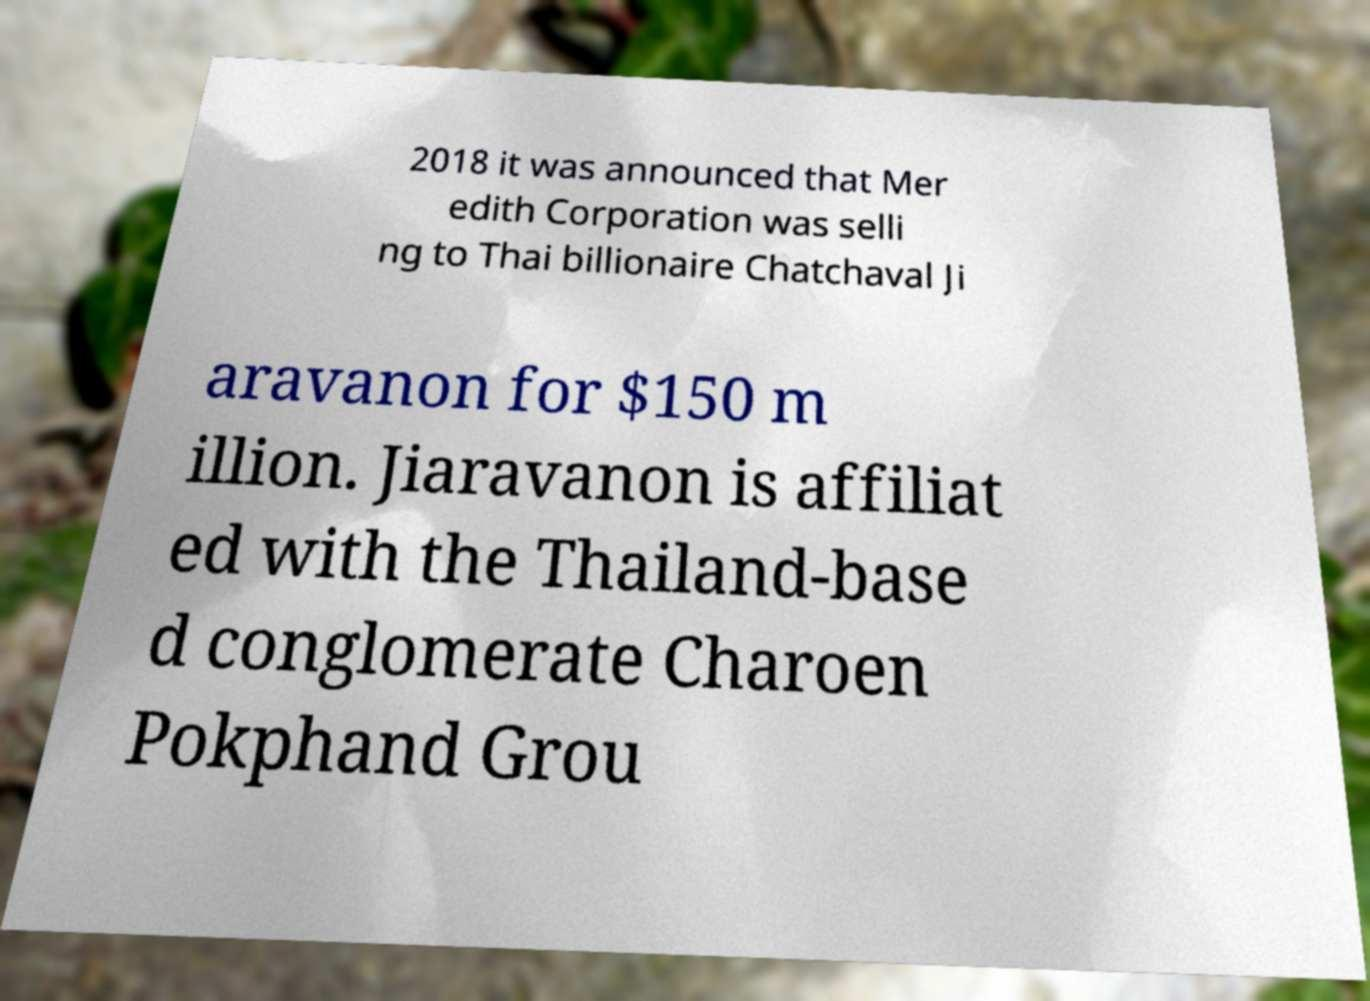What messages or text are displayed in this image? I need them in a readable, typed format. 2018 it was announced that Mer edith Corporation was selli ng to Thai billionaire Chatchaval Ji aravanon for $150 m illion. Jiaravanon is affiliat ed with the Thailand-base d conglomerate Charoen Pokphand Grou 